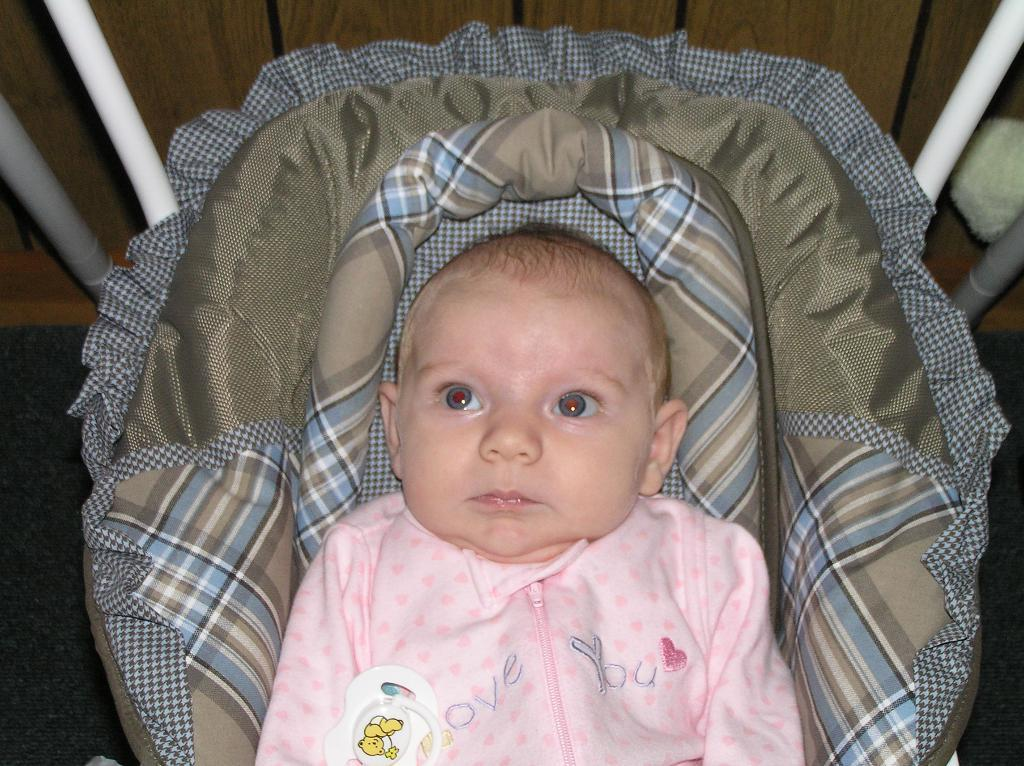What is the main subject of the image? There is a baby in the image. How is the baby positioned in the image? The baby is in a carrier. Where is the carrier placed? The carrier is placed on the ground. What type of basin is being used to scare away the crows in the image? There is no basin or scarecrow present in the image; it features a baby in a carrier placed on the ground. 